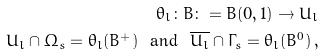<formula> <loc_0><loc_0><loc_500><loc_500>\theta _ { l } \colon B \colon = B ( 0 , 1 ) \rightarrow U _ { l } \\ U _ { l } \cap { \Omega _ { s } } = \theta _ { l } ( B ^ { + } ) \ \text { and } \ \overline { U _ { l } } \cap { \Gamma _ { s } } = \theta _ { l } ( B ^ { 0 } ) \, ,</formula> 